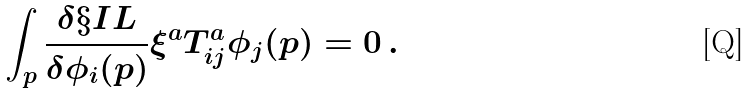<formula> <loc_0><loc_0><loc_500><loc_500>\int _ { p } \frac { \delta \S I L } { \delta \phi _ { i } ( p ) } \xi ^ { a } T ^ { a } _ { i j } \phi _ { j } ( p ) = 0 \, .</formula> 